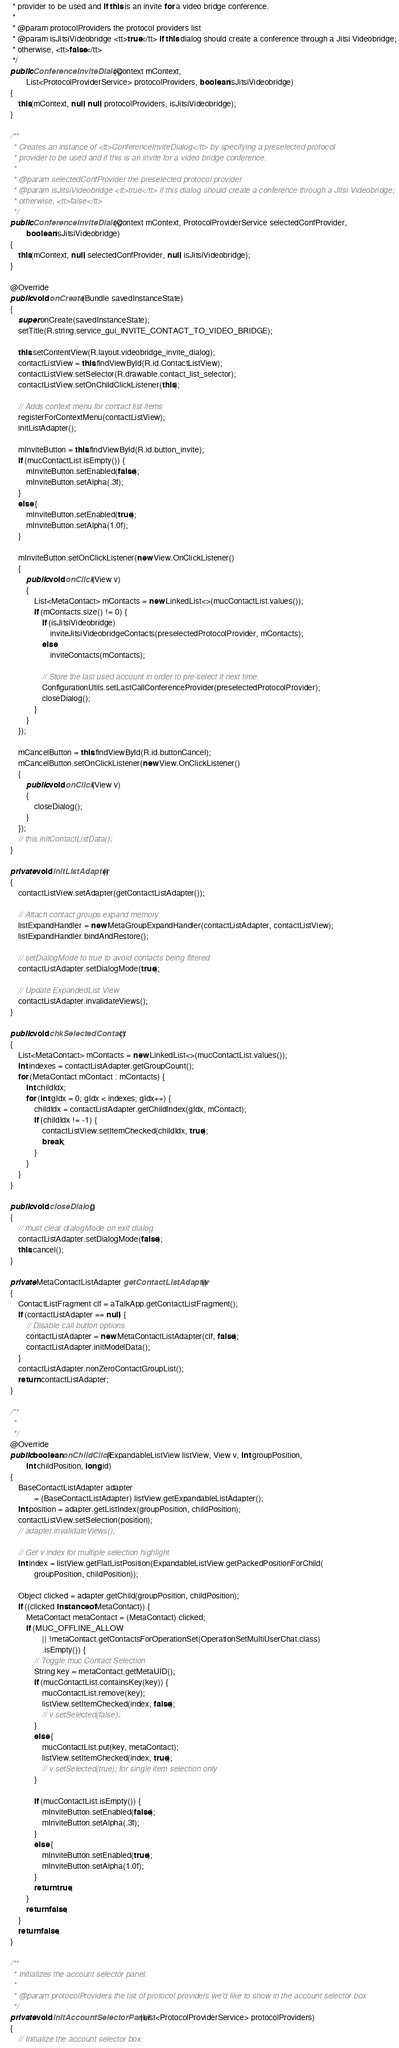Convert code to text. <code><loc_0><loc_0><loc_500><loc_500><_Java_>     * provider to be used and if this is an invite for a video bridge conference.
     *
     * @param protocolProviders the protocol providers list
     * @param isJitsiVideobridge <tt>true</tt> if this dialog should create a conference through a Jitsi Videobridge;
     * otherwise, <tt>false</tt>
     */
    public ConferenceInviteDialog(Context mContext,
            List<ProtocolProviderService> protocolProviders, boolean isJitsiVideobridge)
    {
        this(mContext, null, null, protocolProviders, isJitsiVideobridge);
    }

    /**
     * Creates an instance of <tt>ConferenceInviteDialog</tt> by specifying a preselected protocol
     * provider to be used and if this is an invite for a video bridge conference.
     *
     * @param selectedConfProvider the preselected protocol provider
     * @param isJitsiVideobridge <tt>true</tt> if this dialog should create a conference through a Jitsi Videobridge;
     * otherwise, <tt>false</tt>
     */
    public ConferenceInviteDialog(Context mContext, ProtocolProviderService selectedConfProvider,
            boolean isJitsiVideobridge)
    {
        this(mContext, null, selectedConfProvider, null, isJitsiVideobridge);
    }

    @Override
    public void onCreate(Bundle savedInstanceState)
    {
        super.onCreate(savedInstanceState);
        setTitle(R.string.service_gui_INVITE_CONTACT_TO_VIDEO_BRIDGE);

        this.setContentView(R.layout.videobridge_invite_dialog);
        contactListView = this.findViewById(R.id.ContactListView);
        contactListView.setSelector(R.drawable.contact_list_selector);
        contactListView.setOnChildClickListener(this);

        // Adds context menu for contact list items
        registerForContextMenu(contactListView);
        initListAdapter();

        mInviteButton = this.findViewById(R.id.button_invite);
        if (mucContactList.isEmpty()) {
            mInviteButton.setEnabled(false);
            mInviteButton.setAlpha(.3f);
        }
        else {
            mInviteButton.setEnabled(true);
            mInviteButton.setAlpha(1.0f);
        }

        mInviteButton.setOnClickListener(new View.OnClickListener()
        {
            public void onClick(View v)
            {
                List<MetaContact> mContacts = new LinkedList<>(mucContactList.values());
                if (mContacts.size() != 0) {
                    if (isJitsiVideobridge)
                        inviteJitsiVideobridgeContacts(preselectedProtocolProvider, mContacts);
                    else
                        inviteContacts(mContacts);

                    // Store the last used account in order to pre-select it next time.
                    ConfigurationUtils.setLastCallConferenceProvider(preselectedProtocolProvider);
                    closeDialog();
                }
            }
        });

        mCancelButton = this.findViewById(R.id.buttonCancel);
        mCancelButton.setOnClickListener(new View.OnClickListener()
        {
            public void onClick(View v)
            {
                closeDialog();
            }
        });
        // this.initContactListData();
    }

    private void initListAdapter()
    {
        contactListView.setAdapter(getContactListAdapter());

        // Attach contact groups expand memory
        listExpandHandler = new MetaGroupExpandHandler(contactListAdapter, contactListView);
        listExpandHandler.bindAndRestore();

        // setDialogMode to true to avoid contacts being filtered
        contactListAdapter.setDialogMode(true);

        // Update ExpandedList View
        contactListAdapter.invalidateViews();
    }

    public void chkSelectedContact()
    {
        List<MetaContact> mContacts = new LinkedList<>(mucContactList.values());
        int indexes = contactListAdapter.getGroupCount();
        for (MetaContact mContact : mContacts) {
            int childIdx;
            for (int gIdx = 0; gIdx < indexes; gIdx++) {
                childIdx = contactListAdapter.getChildIndex(gIdx, mContact);
                if (childIdx != -1) {
                    contactListView.setItemChecked(childIdx, true);
                    break;
                }
            }
        }
    }

    public void closeDialog()
    {
        // must clear dialogMode on exit dialog
        contactListAdapter.setDialogMode(false);
        this.cancel();
    }

    private MetaContactListAdapter getContactListAdapter()
    {
        ContactListFragment clf = aTalkApp.getContactListFragment();
        if (contactListAdapter == null) {
            // Disable call button options
            contactListAdapter = new MetaContactListAdapter(clf, false);
            contactListAdapter.initModelData();
        }
        contactListAdapter.nonZeroContactGroupList();
        return contactListAdapter;
    }

    /**
     *
     */
    @Override
    public boolean onChildClick(ExpandableListView listView, View v, int groupPosition,
            int childPosition, long id)
    {
        BaseContactListAdapter adapter
                = (BaseContactListAdapter) listView.getExpandableListAdapter();
        int position = adapter.getListIndex(groupPosition, childPosition);
        contactListView.setSelection(position);
        // adapter.invalidateViews();

        // Get v index for multiple selection highlight
        int index = listView.getFlatListPosition(ExpandableListView.getPackedPositionForChild(
                groupPosition, childPosition));

        Object clicked = adapter.getChild(groupPosition, childPosition);
        if ((clicked instanceof MetaContact)) {
            MetaContact metaContact = (MetaContact) clicked;
            if (MUC_OFFLINE_ALLOW
                    || !metaContact.getContactsForOperationSet(OperationSetMultiUserChat.class)
                    .isEmpty()) {
                // Toggle muc Contact Selection
                String key = metaContact.getMetaUID();
                if (mucContactList.containsKey(key)) {
                    mucContactList.remove(key);
                    listView.setItemChecked(index, false);
                    // v.setSelected(false);
                }
                else {
                    mucContactList.put(key, metaContact);
                    listView.setItemChecked(index, true);
                    // v.setSelected(true); for single item selection only
                }

                if (mucContactList.isEmpty()) {
                    mInviteButton.setEnabled(false);
                    mInviteButton.setAlpha(.3f);
                }
                else {
                    mInviteButton.setEnabled(true);
                    mInviteButton.setAlpha(1.0f);
                }
                return true;
            }
            return false;
        }
        return false;
    }

    /**
     * Initializes the account selector panel.
     *
     * @param protocolProviders the list of protocol providers we'd like to show in the account selector box
     */
    private void initAccountSelectorPanel(List<ProtocolProviderService> protocolProviders)
    {
        // Initialize the account selector box.</code> 